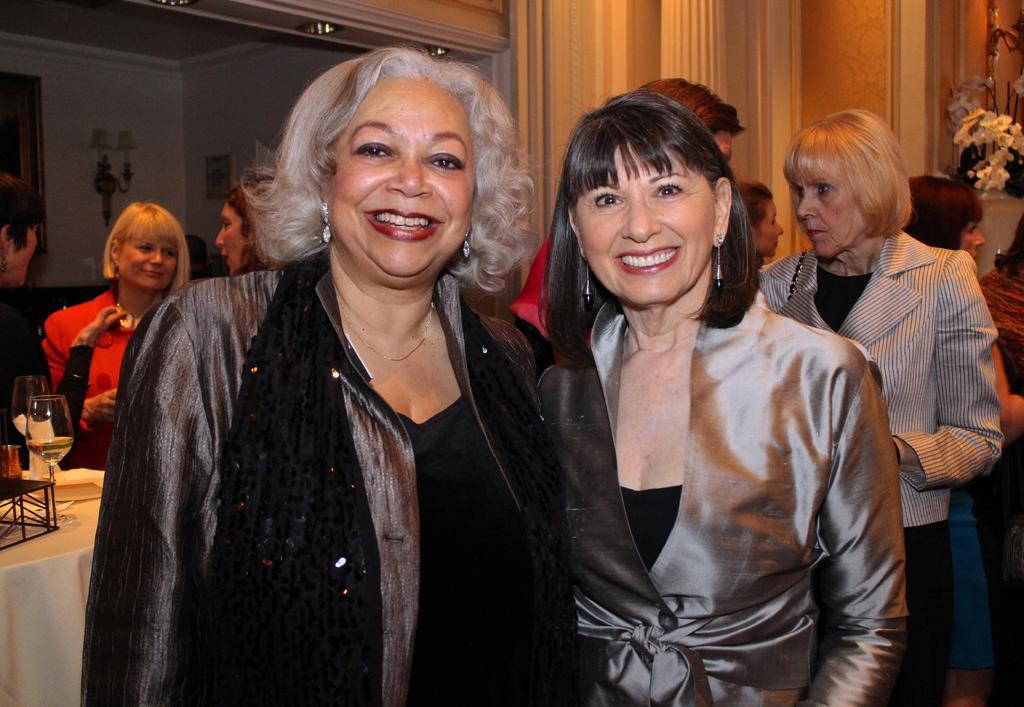Describe this image in one or two sentences. In this picture I can see there are two women standing, they are smiling and in the backdrop, I can see there are few other women standing, there is a table at the left side, I can see there is a wine glass, tissues on it. There is a flower vase at the right side. There are few lights and there is a wall in the backdrop. 